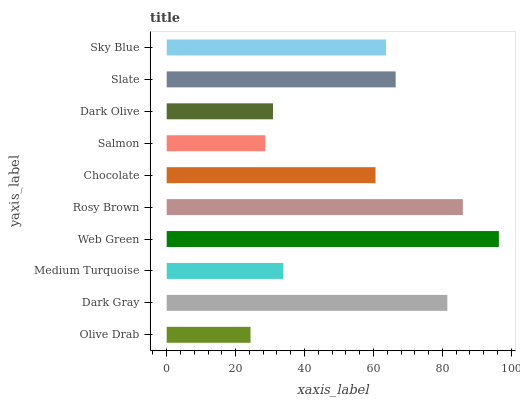Is Olive Drab the minimum?
Answer yes or no. Yes. Is Web Green the maximum?
Answer yes or no. Yes. Is Dark Gray the minimum?
Answer yes or no. No. Is Dark Gray the maximum?
Answer yes or no. No. Is Dark Gray greater than Olive Drab?
Answer yes or no. Yes. Is Olive Drab less than Dark Gray?
Answer yes or no. Yes. Is Olive Drab greater than Dark Gray?
Answer yes or no. No. Is Dark Gray less than Olive Drab?
Answer yes or no. No. Is Sky Blue the high median?
Answer yes or no. Yes. Is Chocolate the low median?
Answer yes or no. Yes. Is Chocolate the high median?
Answer yes or no. No. Is Medium Turquoise the low median?
Answer yes or no. No. 